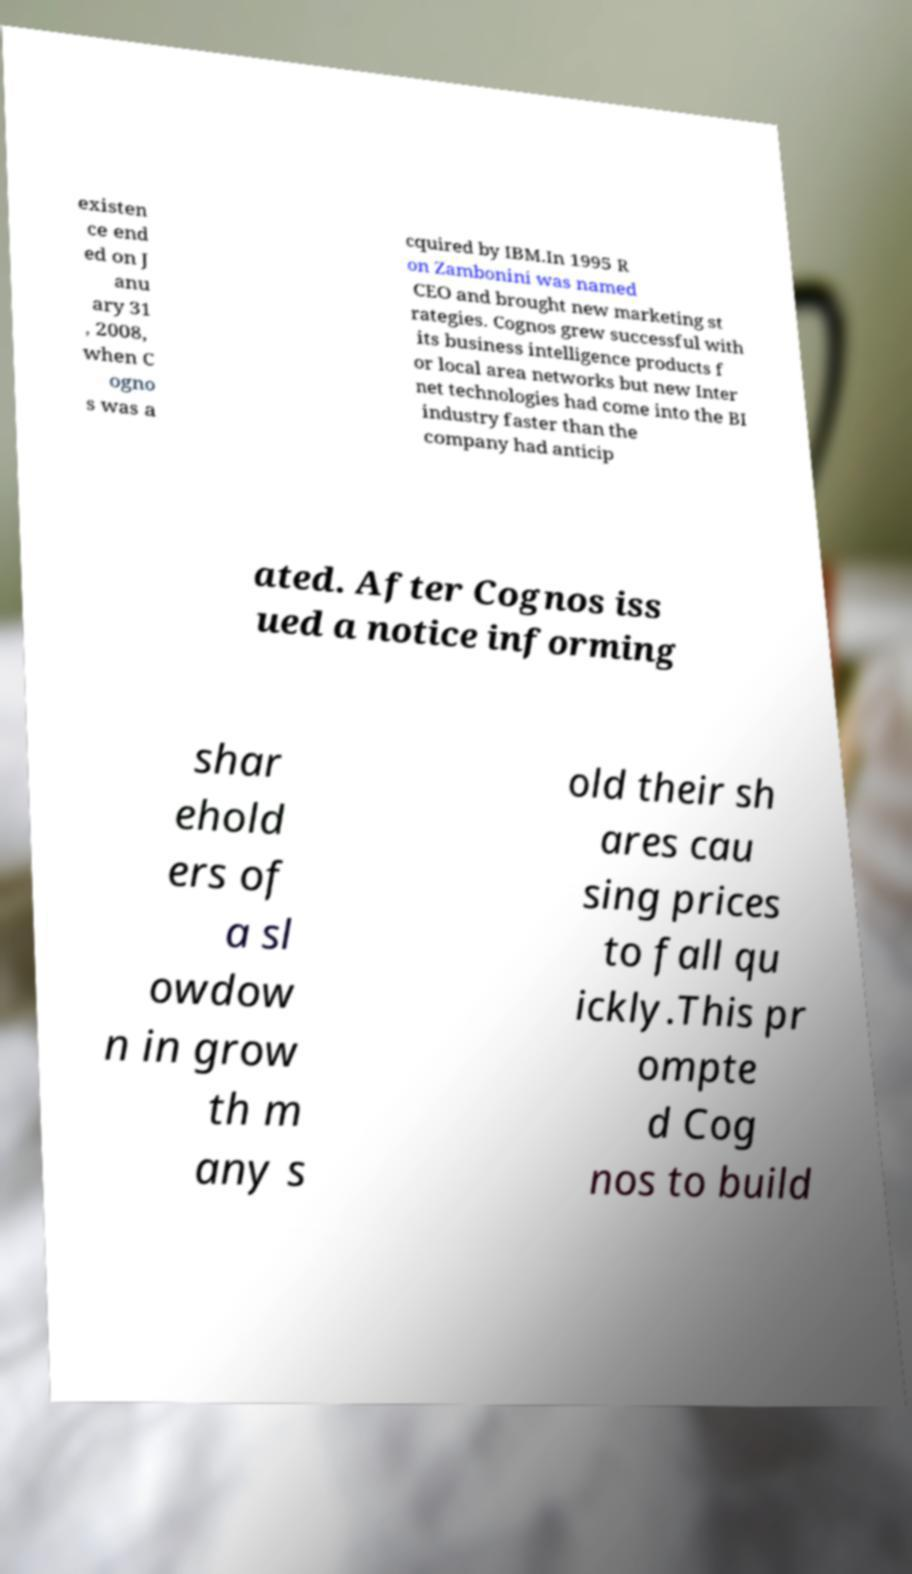Could you extract and type out the text from this image? existen ce end ed on J anu ary 31 , 2008, when C ogno s was a cquired by IBM.In 1995 R on Zambonini was named CEO and brought new marketing st rategies. Cognos grew successful with its business intelligence products f or local area networks but new Inter net technologies had come into the BI industry faster than the company had anticip ated. After Cognos iss ued a notice informing shar ehold ers of a sl owdow n in grow th m any s old their sh ares cau sing prices to fall qu ickly.This pr ompte d Cog nos to build 